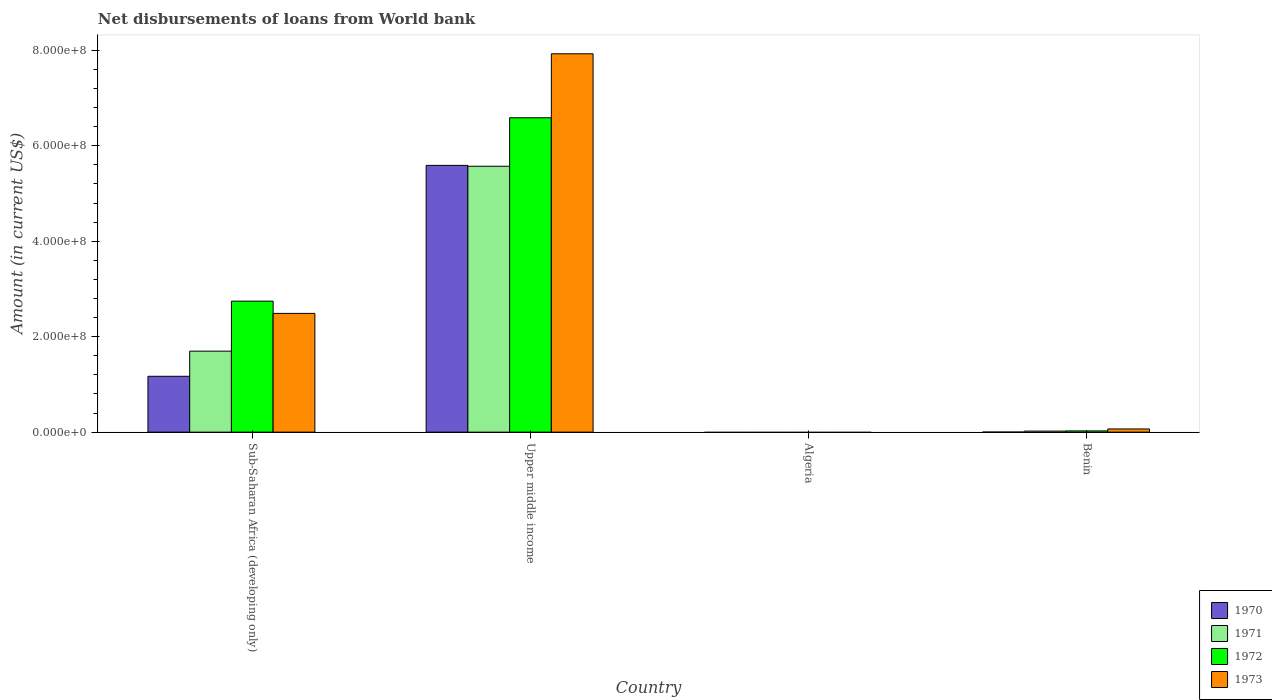How many different coloured bars are there?
Provide a succinct answer. 4. Are the number of bars on each tick of the X-axis equal?
Make the answer very short. No. What is the label of the 4th group of bars from the left?
Your answer should be very brief. Benin. What is the amount of loan disbursed from World Bank in 1973 in Sub-Saharan Africa (developing only)?
Ensure brevity in your answer.  2.49e+08. Across all countries, what is the maximum amount of loan disbursed from World Bank in 1973?
Provide a succinct answer. 7.93e+08. Across all countries, what is the minimum amount of loan disbursed from World Bank in 1973?
Keep it short and to the point. 0. In which country was the amount of loan disbursed from World Bank in 1970 maximum?
Provide a succinct answer. Upper middle income. What is the total amount of loan disbursed from World Bank in 1971 in the graph?
Make the answer very short. 7.29e+08. What is the difference between the amount of loan disbursed from World Bank in 1972 in Benin and that in Sub-Saharan Africa (developing only)?
Provide a succinct answer. -2.72e+08. What is the difference between the amount of loan disbursed from World Bank in 1973 in Benin and the amount of loan disbursed from World Bank in 1971 in Sub-Saharan Africa (developing only)?
Keep it short and to the point. -1.63e+08. What is the average amount of loan disbursed from World Bank in 1971 per country?
Your answer should be compact. 1.82e+08. What is the difference between the amount of loan disbursed from World Bank of/in 1972 and amount of loan disbursed from World Bank of/in 1973 in Benin?
Ensure brevity in your answer.  -4.09e+06. In how many countries, is the amount of loan disbursed from World Bank in 1973 greater than 320000000 US$?
Offer a terse response. 1. What is the ratio of the amount of loan disbursed from World Bank in 1973 in Sub-Saharan Africa (developing only) to that in Upper middle income?
Make the answer very short. 0.31. Is the amount of loan disbursed from World Bank in 1970 in Sub-Saharan Africa (developing only) less than that in Upper middle income?
Ensure brevity in your answer.  Yes. Is the difference between the amount of loan disbursed from World Bank in 1972 in Sub-Saharan Africa (developing only) and Upper middle income greater than the difference between the amount of loan disbursed from World Bank in 1973 in Sub-Saharan Africa (developing only) and Upper middle income?
Give a very brief answer. Yes. What is the difference between the highest and the second highest amount of loan disbursed from World Bank in 1970?
Your answer should be very brief. 5.59e+08. What is the difference between the highest and the lowest amount of loan disbursed from World Bank in 1971?
Your answer should be compact. 5.57e+08. In how many countries, is the amount of loan disbursed from World Bank in 1972 greater than the average amount of loan disbursed from World Bank in 1972 taken over all countries?
Provide a succinct answer. 2. Is it the case that in every country, the sum of the amount of loan disbursed from World Bank in 1971 and amount of loan disbursed from World Bank in 1973 is greater than the sum of amount of loan disbursed from World Bank in 1970 and amount of loan disbursed from World Bank in 1972?
Provide a short and direct response. No. Is it the case that in every country, the sum of the amount of loan disbursed from World Bank in 1971 and amount of loan disbursed from World Bank in 1970 is greater than the amount of loan disbursed from World Bank in 1973?
Offer a very short reply. No. Where does the legend appear in the graph?
Your answer should be very brief. Bottom right. How are the legend labels stacked?
Ensure brevity in your answer.  Vertical. What is the title of the graph?
Your answer should be very brief. Net disbursements of loans from World bank. Does "1963" appear as one of the legend labels in the graph?
Make the answer very short. No. What is the label or title of the Y-axis?
Your answer should be very brief. Amount (in current US$). What is the Amount (in current US$) in 1970 in Sub-Saharan Africa (developing only)?
Provide a succinct answer. 1.17e+08. What is the Amount (in current US$) of 1971 in Sub-Saharan Africa (developing only)?
Offer a terse response. 1.70e+08. What is the Amount (in current US$) of 1972 in Sub-Saharan Africa (developing only)?
Offer a terse response. 2.74e+08. What is the Amount (in current US$) in 1973 in Sub-Saharan Africa (developing only)?
Offer a terse response. 2.49e+08. What is the Amount (in current US$) of 1970 in Upper middle income?
Keep it short and to the point. 5.59e+08. What is the Amount (in current US$) in 1971 in Upper middle income?
Offer a very short reply. 5.57e+08. What is the Amount (in current US$) in 1972 in Upper middle income?
Offer a very short reply. 6.59e+08. What is the Amount (in current US$) in 1973 in Upper middle income?
Give a very brief answer. 7.93e+08. What is the Amount (in current US$) in 1970 in Benin?
Your answer should be very brief. 1.45e+05. What is the Amount (in current US$) in 1971 in Benin?
Provide a succinct answer. 2.19e+06. What is the Amount (in current US$) in 1972 in Benin?
Provide a succinct answer. 2.58e+06. What is the Amount (in current US$) of 1973 in Benin?
Offer a terse response. 6.67e+06. Across all countries, what is the maximum Amount (in current US$) in 1970?
Your answer should be very brief. 5.59e+08. Across all countries, what is the maximum Amount (in current US$) of 1971?
Offer a terse response. 5.57e+08. Across all countries, what is the maximum Amount (in current US$) in 1972?
Keep it short and to the point. 6.59e+08. Across all countries, what is the maximum Amount (in current US$) in 1973?
Your response must be concise. 7.93e+08. Across all countries, what is the minimum Amount (in current US$) in 1970?
Your answer should be very brief. 0. Across all countries, what is the minimum Amount (in current US$) in 1971?
Provide a succinct answer. 0. Across all countries, what is the minimum Amount (in current US$) of 1973?
Your response must be concise. 0. What is the total Amount (in current US$) in 1970 in the graph?
Your response must be concise. 6.76e+08. What is the total Amount (in current US$) in 1971 in the graph?
Offer a terse response. 7.29e+08. What is the total Amount (in current US$) of 1972 in the graph?
Make the answer very short. 9.36e+08. What is the total Amount (in current US$) in 1973 in the graph?
Provide a succinct answer. 1.05e+09. What is the difference between the Amount (in current US$) of 1970 in Sub-Saharan Africa (developing only) and that in Upper middle income?
Offer a terse response. -4.42e+08. What is the difference between the Amount (in current US$) of 1971 in Sub-Saharan Africa (developing only) and that in Upper middle income?
Keep it short and to the point. -3.87e+08. What is the difference between the Amount (in current US$) in 1972 in Sub-Saharan Africa (developing only) and that in Upper middle income?
Provide a succinct answer. -3.84e+08. What is the difference between the Amount (in current US$) of 1973 in Sub-Saharan Africa (developing only) and that in Upper middle income?
Your answer should be very brief. -5.44e+08. What is the difference between the Amount (in current US$) of 1970 in Sub-Saharan Africa (developing only) and that in Benin?
Your answer should be very brief. 1.17e+08. What is the difference between the Amount (in current US$) of 1971 in Sub-Saharan Africa (developing only) and that in Benin?
Offer a very short reply. 1.68e+08. What is the difference between the Amount (in current US$) in 1972 in Sub-Saharan Africa (developing only) and that in Benin?
Your answer should be very brief. 2.72e+08. What is the difference between the Amount (in current US$) in 1973 in Sub-Saharan Africa (developing only) and that in Benin?
Provide a short and direct response. 2.42e+08. What is the difference between the Amount (in current US$) of 1970 in Upper middle income and that in Benin?
Give a very brief answer. 5.59e+08. What is the difference between the Amount (in current US$) in 1971 in Upper middle income and that in Benin?
Offer a terse response. 5.55e+08. What is the difference between the Amount (in current US$) of 1972 in Upper middle income and that in Benin?
Your response must be concise. 6.56e+08. What is the difference between the Amount (in current US$) in 1973 in Upper middle income and that in Benin?
Give a very brief answer. 7.86e+08. What is the difference between the Amount (in current US$) in 1970 in Sub-Saharan Africa (developing only) and the Amount (in current US$) in 1971 in Upper middle income?
Offer a very short reply. -4.40e+08. What is the difference between the Amount (in current US$) in 1970 in Sub-Saharan Africa (developing only) and the Amount (in current US$) in 1972 in Upper middle income?
Offer a terse response. -5.42e+08. What is the difference between the Amount (in current US$) in 1970 in Sub-Saharan Africa (developing only) and the Amount (in current US$) in 1973 in Upper middle income?
Provide a short and direct response. -6.76e+08. What is the difference between the Amount (in current US$) in 1971 in Sub-Saharan Africa (developing only) and the Amount (in current US$) in 1972 in Upper middle income?
Your answer should be very brief. -4.89e+08. What is the difference between the Amount (in current US$) of 1971 in Sub-Saharan Africa (developing only) and the Amount (in current US$) of 1973 in Upper middle income?
Give a very brief answer. -6.23e+08. What is the difference between the Amount (in current US$) in 1972 in Sub-Saharan Africa (developing only) and the Amount (in current US$) in 1973 in Upper middle income?
Your response must be concise. -5.18e+08. What is the difference between the Amount (in current US$) in 1970 in Sub-Saharan Africa (developing only) and the Amount (in current US$) in 1971 in Benin?
Give a very brief answer. 1.15e+08. What is the difference between the Amount (in current US$) of 1970 in Sub-Saharan Africa (developing only) and the Amount (in current US$) of 1972 in Benin?
Offer a terse response. 1.14e+08. What is the difference between the Amount (in current US$) of 1970 in Sub-Saharan Africa (developing only) and the Amount (in current US$) of 1973 in Benin?
Give a very brief answer. 1.10e+08. What is the difference between the Amount (in current US$) of 1971 in Sub-Saharan Africa (developing only) and the Amount (in current US$) of 1972 in Benin?
Keep it short and to the point. 1.67e+08. What is the difference between the Amount (in current US$) of 1971 in Sub-Saharan Africa (developing only) and the Amount (in current US$) of 1973 in Benin?
Your answer should be very brief. 1.63e+08. What is the difference between the Amount (in current US$) of 1972 in Sub-Saharan Africa (developing only) and the Amount (in current US$) of 1973 in Benin?
Ensure brevity in your answer.  2.68e+08. What is the difference between the Amount (in current US$) of 1970 in Upper middle income and the Amount (in current US$) of 1971 in Benin?
Your answer should be very brief. 5.57e+08. What is the difference between the Amount (in current US$) in 1970 in Upper middle income and the Amount (in current US$) in 1972 in Benin?
Make the answer very short. 5.56e+08. What is the difference between the Amount (in current US$) in 1970 in Upper middle income and the Amount (in current US$) in 1973 in Benin?
Give a very brief answer. 5.52e+08. What is the difference between the Amount (in current US$) in 1971 in Upper middle income and the Amount (in current US$) in 1972 in Benin?
Offer a very short reply. 5.55e+08. What is the difference between the Amount (in current US$) of 1971 in Upper middle income and the Amount (in current US$) of 1973 in Benin?
Your answer should be compact. 5.50e+08. What is the difference between the Amount (in current US$) in 1972 in Upper middle income and the Amount (in current US$) in 1973 in Benin?
Keep it short and to the point. 6.52e+08. What is the average Amount (in current US$) of 1970 per country?
Your response must be concise. 1.69e+08. What is the average Amount (in current US$) in 1971 per country?
Offer a terse response. 1.82e+08. What is the average Amount (in current US$) of 1972 per country?
Offer a terse response. 2.34e+08. What is the average Amount (in current US$) of 1973 per country?
Offer a very short reply. 2.62e+08. What is the difference between the Amount (in current US$) of 1970 and Amount (in current US$) of 1971 in Sub-Saharan Africa (developing only)?
Offer a very short reply. -5.27e+07. What is the difference between the Amount (in current US$) of 1970 and Amount (in current US$) of 1972 in Sub-Saharan Africa (developing only)?
Provide a short and direct response. -1.57e+08. What is the difference between the Amount (in current US$) of 1970 and Amount (in current US$) of 1973 in Sub-Saharan Africa (developing only)?
Provide a short and direct response. -1.32e+08. What is the difference between the Amount (in current US$) in 1971 and Amount (in current US$) in 1972 in Sub-Saharan Africa (developing only)?
Make the answer very short. -1.05e+08. What is the difference between the Amount (in current US$) of 1971 and Amount (in current US$) of 1973 in Sub-Saharan Africa (developing only)?
Ensure brevity in your answer.  -7.91e+07. What is the difference between the Amount (in current US$) of 1972 and Amount (in current US$) of 1973 in Sub-Saharan Africa (developing only)?
Give a very brief answer. 2.57e+07. What is the difference between the Amount (in current US$) of 1970 and Amount (in current US$) of 1971 in Upper middle income?
Give a very brief answer. 1.84e+06. What is the difference between the Amount (in current US$) in 1970 and Amount (in current US$) in 1972 in Upper middle income?
Provide a short and direct response. -9.98e+07. What is the difference between the Amount (in current US$) in 1970 and Amount (in current US$) in 1973 in Upper middle income?
Provide a short and direct response. -2.34e+08. What is the difference between the Amount (in current US$) of 1971 and Amount (in current US$) of 1972 in Upper middle income?
Your answer should be very brief. -1.02e+08. What is the difference between the Amount (in current US$) of 1971 and Amount (in current US$) of 1973 in Upper middle income?
Ensure brevity in your answer.  -2.36e+08. What is the difference between the Amount (in current US$) of 1972 and Amount (in current US$) of 1973 in Upper middle income?
Your answer should be compact. -1.34e+08. What is the difference between the Amount (in current US$) in 1970 and Amount (in current US$) in 1971 in Benin?
Provide a short and direct response. -2.04e+06. What is the difference between the Amount (in current US$) in 1970 and Amount (in current US$) in 1972 in Benin?
Offer a terse response. -2.43e+06. What is the difference between the Amount (in current US$) of 1970 and Amount (in current US$) of 1973 in Benin?
Ensure brevity in your answer.  -6.53e+06. What is the difference between the Amount (in current US$) in 1971 and Amount (in current US$) in 1972 in Benin?
Provide a short and direct response. -3.92e+05. What is the difference between the Amount (in current US$) of 1971 and Amount (in current US$) of 1973 in Benin?
Your answer should be very brief. -4.49e+06. What is the difference between the Amount (in current US$) of 1972 and Amount (in current US$) of 1973 in Benin?
Give a very brief answer. -4.09e+06. What is the ratio of the Amount (in current US$) of 1970 in Sub-Saharan Africa (developing only) to that in Upper middle income?
Give a very brief answer. 0.21. What is the ratio of the Amount (in current US$) of 1971 in Sub-Saharan Africa (developing only) to that in Upper middle income?
Your answer should be very brief. 0.3. What is the ratio of the Amount (in current US$) of 1972 in Sub-Saharan Africa (developing only) to that in Upper middle income?
Offer a very short reply. 0.42. What is the ratio of the Amount (in current US$) of 1973 in Sub-Saharan Africa (developing only) to that in Upper middle income?
Make the answer very short. 0.31. What is the ratio of the Amount (in current US$) in 1970 in Sub-Saharan Africa (developing only) to that in Benin?
Offer a terse response. 807.17. What is the ratio of the Amount (in current US$) of 1971 in Sub-Saharan Africa (developing only) to that in Benin?
Make the answer very short. 77.64. What is the ratio of the Amount (in current US$) in 1972 in Sub-Saharan Africa (developing only) to that in Benin?
Your answer should be very brief. 106.47. What is the ratio of the Amount (in current US$) of 1973 in Sub-Saharan Africa (developing only) to that in Benin?
Make the answer very short. 37.29. What is the ratio of the Amount (in current US$) of 1970 in Upper middle income to that in Benin?
Provide a succinct answer. 3854.79. What is the ratio of the Amount (in current US$) in 1971 in Upper middle income to that in Benin?
Give a very brief answer. 254.85. What is the ratio of the Amount (in current US$) of 1972 in Upper middle income to that in Benin?
Your answer should be compact. 255.52. What is the ratio of the Amount (in current US$) in 1973 in Upper middle income to that in Benin?
Provide a succinct answer. 118.82. What is the difference between the highest and the second highest Amount (in current US$) in 1970?
Make the answer very short. 4.42e+08. What is the difference between the highest and the second highest Amount (in current US$) of 1971?
Provide a succinct answer. 3.87e+08. What is the difference between the highest and the second highest Amount (in current US$) in 1972?
Keep it short and to the point. 3.84e+08. What is the difference between the highest and the second highest Amount (in current US$) in 1973?
Make the answer very short. 5.44e+08. What is the difference between the highest and the lowest Amount (in current US$) of 1970?
Provide a short and direct response. 5.59e+08. What is the difference between the highest and the lowest Amount (in current US$) of 1971?
Your answer should be very brief. 5.57e+08. What is the difference between the highest and the lowest Amount (in current US$) in 1972?
Ensure brevity in your answer.  6.59e+08. What is the difference between the highest and the lowest Amount (in current US$) in 1973?
Give a very brief answer. 7.93e+08. 